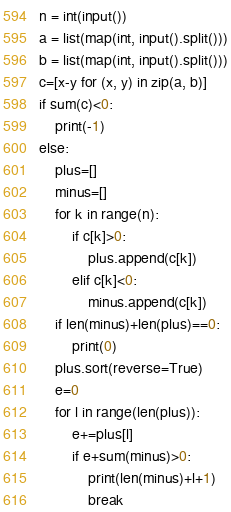Convert code to text. <code><loc_0><loc_0><loc_500><loc_500><_Python_>n = int(input())
a = list(map(int, input().split()))
b = list(map(int, input().split()))
c=[x-y for (x, y) in zip(a, b)]
if sum(c)<0:
    print(-1)
else:
    plus=[]
    minus=[]
    for k in range(n):
        if c[k]>0:
            plus.append(c[k])
        elif c[k]<0:
            minus.append(c[k])
    if len(minus)+len(plus)==0:
        print(0)
    plus.sort(reverse=True)
    e=0
    for l in range(len(plus)):
        e+=plus[l]
        if e+sum(minus)>0:
            print(len(minus)+l+1)
            break </code> 